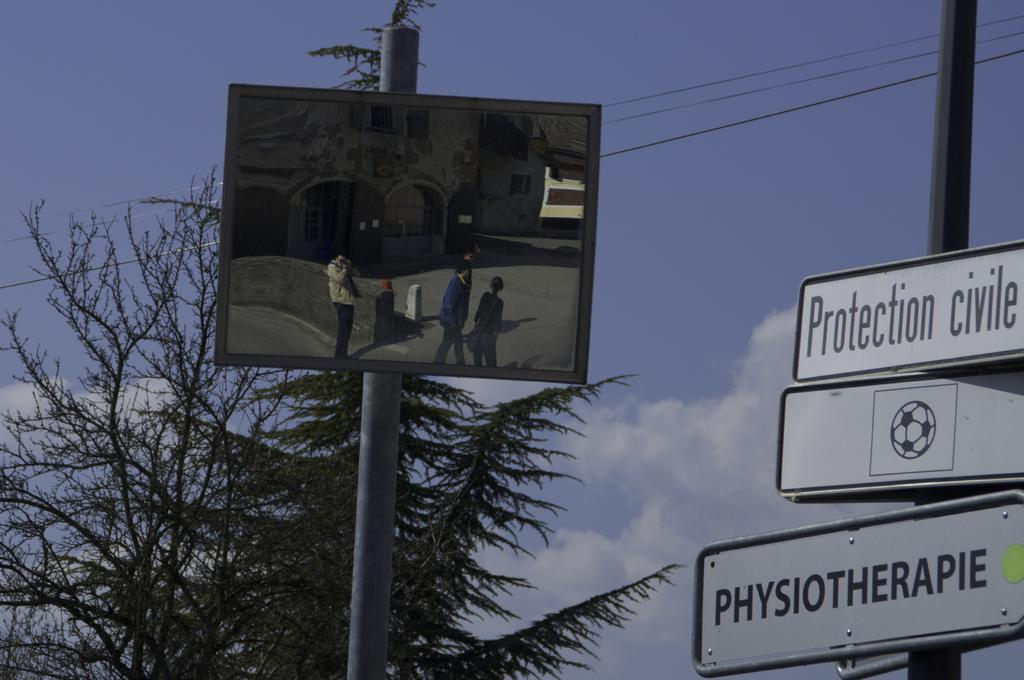What objects can be seen in the image that are used for support or structure? There are boards and poles in the image that are used for support or structure. What type of natural element is present in the image? There is a tree in the image. What is the weather like in the image? The sky is cloudy in the image, suggesting overcast or potentially rainy weather. What is written on the boards in the image? Something is written on the boards in the image, but the specific message cannot be determined from the facts provided. Who or what is present in the image in addition to the objects and natural elements? There are people in the image. What type of man-made structures can be seen in the image? There are buildings in the image. Can you hear the bell ringing in the image? There is no bell present in the image, so it cannot be heard. Is the sister of the person taking the image also visible in the image? There is no mention of a sister or any other specific individuals in the image, so it cannot be determined if she is present. 